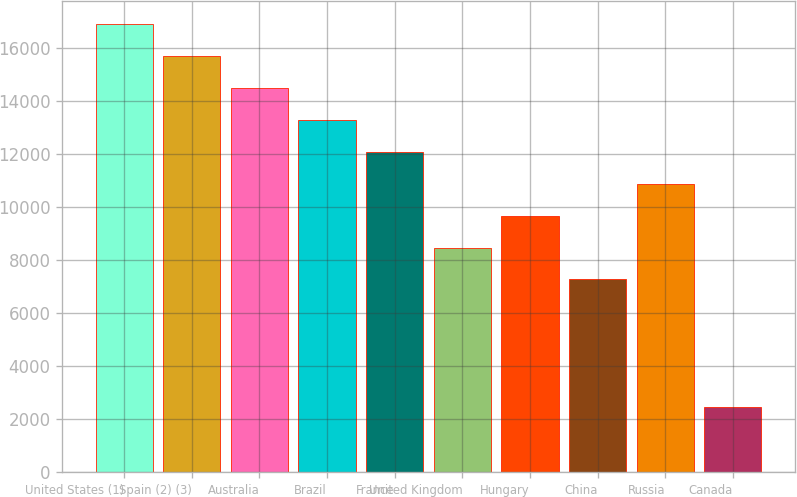Convert chart. <chart><loc_0><loc_0><loc_500><loc_500><bar_chart><fcel>United States (1)<fcel>Spain (2) (3)<fcel>Australia<fcel>Brazil<fcel>France<fcel>United Kingdom<fcel>Hungary<fcel>China<fcel>Russia<fcel>Canada<nl><fcel>16931.8<fcel>15724.6<fcel>14517.4<fcel>13310.2<fcel>12103<fcel>8481.4<fcel>9688.6<fcel>7274.2<fcel>10895.8<fcel>2445.4<nl></chart> 